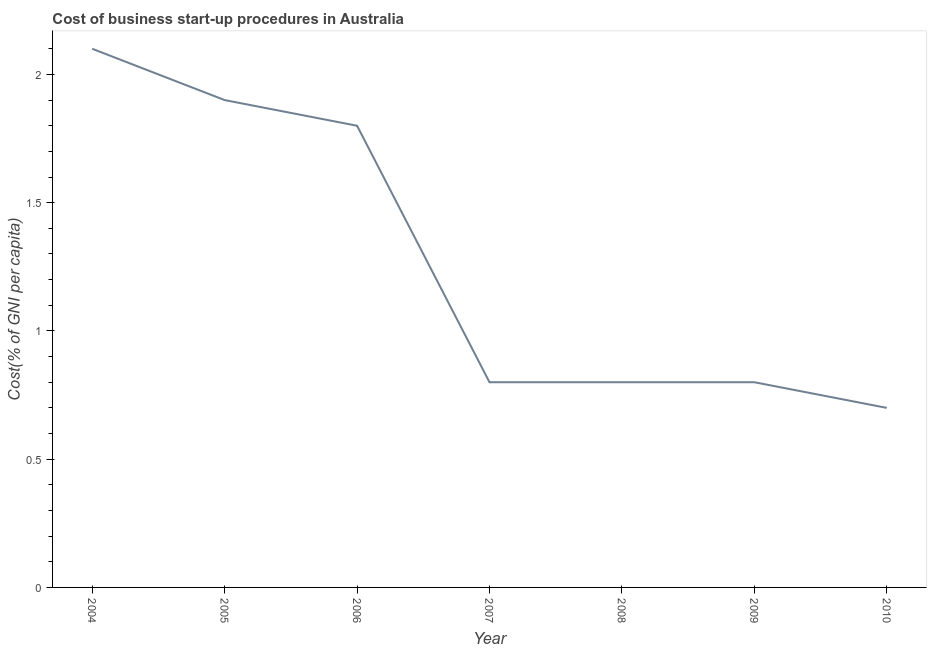What is the cost of business startup procedures in 2006?
Keep it short and to the point. 1.8. Across all years, what is the minimum cost of business startup procedures?
Make the answer very short. 0.7. In which year was the cost of business startup procedures maximum?
Make the answer very short. 2004. What is the sum of the cost of business startup procedures?
Your response must be concise. 8.9. What is the difference between the cost of business startup procedures in 2006 and 2007?
Provide a short and direct response. 1. What is the average cost of business startup procedures per year?
Your response must be concise. 1.27. What is the median cost of business startup procedures?
Your response must be concise. 0.8. In how many years, is the cost of business startup procedures greater than 0.9 %?
Offer a very short reply. 3. What is the ratio of the cost of business startup procedures in 2004 to that in 2007?
Give a very brief answer. 2.62. Is the cost of business startup procedures in 2005 less than that in 2006?
Provide a short and direct response. No. Is the difference between the cost of business startup procedures in 2005 and 2006 greater than the difference between any two years?
Offer a very short reply. No. What is the difference between the highest and the second highest cost of business startup procedures?
Provide a short and direct response. 0.2. Is the sum of the cost of business startup procedures in 2007 and 2009 greater than the maximum cost of business startup procedures across all years?
Your answer should be very brief. No. What is the difference between the highest and the lowest cost of business startup procedures?
Your answer should be compact. 1.4. How many years are there in the graph?
Offer a terse response. 7. Are the values on the major ticks of Y-axis written in scientific E-notation?
Make the answer very short. No. Does the graph contain grids?
Your response must be concise. No. What is the title of the graph?
Provide a succinct answer. Cost of business start-up procedures in Australia. What is the label or title of the Y-axis?
Make the answer very short. Cost(% of GNI per capita). What is the Cost(% of GNI per capita) of 2010?
Your answer should be compact. 0.7. What is the difference between the Cost(% of GNI per capita) in 2004 and 2008?
Provide a short and direct response. 1.3. What is the difference between the Cost(% of GNI per capita) in 2004 and 2009?
Keep it short and to the point. 1.3. What is the difference between the Cost(% of GNI per capita) in 2005 and 2006?
Your answer should be compact. 0.1. What is the difference between the Cost(% of GNI per capita) in 2005 and 2007?
Your answer should be compact. 1.1. What is the difference between the Cost(% of GNI per capita) in 2006 and 2008?
Keep it short and to the point. 1. What is the difference between the Cost(% of GNI per capita) in 2006 and 2010?
Provide a short and direct response. 1.1. What is the difference between the Cost(% of GNI per capita) in 2007 and 2008?
Offer a very short reply. 0. What is the difference between the Cost(% of GNI per capita) in 2007 and 2009?
Give a very brief answer. 0. What is the difference between the Cost(% of GNI per capita) in 2007 and 2010?
Make the answer very short. 0.1. What is the difference between the Cost(% of GNI per capita) in 2008 and 2009?
Your response must be concise. 0. What is the difference between the Cost(% of GNI per capita) in 2009 and 2010?
Provide a succinct answer. 0.1. What is the ratio of the Cost(% of GNI per capita) in 2004 to that in 2005?
Make the answer very short. 1.1. What is the ratio of the Cost(% of GNI per capita) in 2004 to that in 2006?
Your answer should be very brief. 1.17. What is the ratio of the Cost(% of GNI per capita) in 2004 to that in 2007?
Offer a terse response. 2.62. What is the ratio of the Cost(% of GNI per capita) in 2004 to that in 2008?
Your response must be concise. 2.62. What is the ratio of the Cost(% of GNI per capita) in 2004 to that in 2009?
Your response must be concise. 2.62. What is the ratio of the Cost(% of GNI per capita) in 2005 to that in 2006?
Your answer should be compact. 1.06. What is the ratio of the Cost(% of GNI per capita) in 2005 to that in 2007?
Your answer should be very brief. 2.38. What is the ratio of the Cost(% of GNI per capita) in 2005 to that in 2008?
Provide a short and direct response. 2.38. What is the ratio of the Cost(% of GNI per capita) in 2005 to that in 2009?
Offer a terse response. 2.38. What is the ratio of the Cost(% of GNI per capita) in 2005 to that in 2010?
Provide a short and direct response. 2.71. What is the ratio of the Cost(% of GNI per capita) in 2006 to that in 2007?
Provide a succinct answer. 2.25. What is the ratio of the Cost(% of GNI per capita) in 2006 to that in 2008?
Provide a succinct answer. 2.25. What is the ratio of the Cost(% of GNI per capita) in 2006 to that in 2009?
Provide a short and direct response. 2.25. What is the ratio of the Cost(% of GNI per capita) in 2006 to that in 2010?
Your answer should be compact. 2.57. What is the ratio of the Cost(% of GNI per capita) in 2007 to that in 2008?
Offer a very short reply. 1. What is the ratio of the Cost(% of GNI per capita) in 2007 to that in 2009?
Keep it short and to the point. 1. What is the ratio of the Cost(% of GNI per capita) in 2007 to that in 2010?
Give a very brief answer. 1.14. What is the ratio of the Cost(% of GNI per capita) in 2008 to that in 2010?
Give a very brief answer. 1.14. What is the ratio of the Cost(% of GNI per capita) in 2009 to that in 2010?
Your response must be concise. 1.14. 